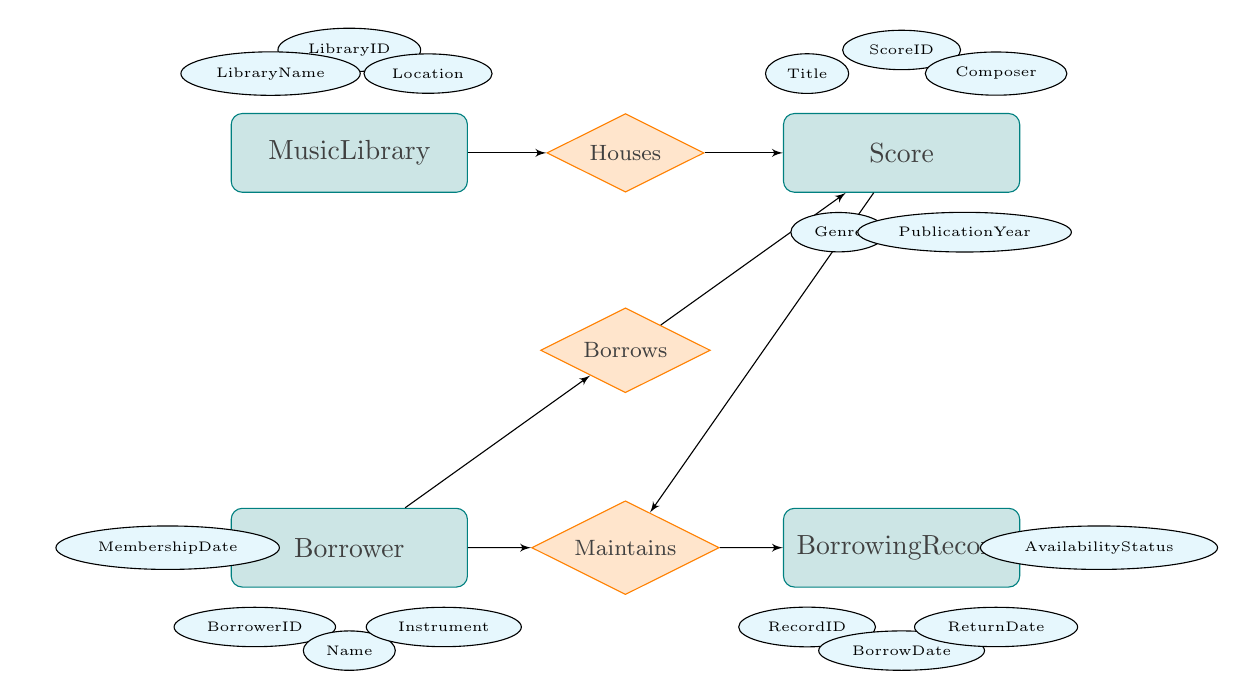What is the title of the Score? The title of the Score is a specific attribute belonging to the Score entity. In the diagram, it's listed as an attribute under the Score entity.
Answer: Title How many entities are represented in the diagram? The diagram shows a total of four entities: MusicLibrary, Score, Borrower, and BorrowingRecord. By counting the distinct entities visually, we can confirm this number.
Answer: 4 What relationship connects Borrower and Score? The relationship that connects Borrower and Score is labeled "Borrows" in the diagram. It illustrates the borrowing activity between these two entities.
Answer: Borrows Which entity has the attribute 'LibraryID'? The attribute 'LibraryID' is associated with the MusicLibrary entity, as indicated in the diagram where the attributes for each entity are listed.
Answer: MusicLibrary Which relationship involves BorrowingRecord? The BorrowingRecord is involved in the "Maintains" relationship, connecting it back to the Borrower and Score entities in the diagram, indicating that there are records of borrowing.
Answer: Maintains What information does the borrowing record track? The BorrowingRecord entity tracks information including BorrowDate, ReturnDate, and AvailabilityStatus, which are specified as attributes of that entity in the diagram.
Answer: BorrowDate, ReturnDate, AvailabilityStatus How many relationships connect the entities in the diagram? There are three relationships connecting the entities shown in the diagram: Houses, Borrows, and Maintains. This is determined by visually counting each relationship line drawn between the entities.
Answer: 3 Which attribute indicates the instrument played by the borrower? The attribute that indicates the instrument played by the borrower is labeled 'Instrument' under the Borrower entity, describing the instrument each borrower plays.
Answer: Instrument What does the relationship 'Houses' exemplify? The 'Houses' relationship exemplifies the connection between the MusicLibrary and Score entities, indicating that a music library holds various scores in its collection, as represented in the diagram.
Answer: Music collection 